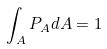Convert formula to latex. <formula><loc_0><loc_0><loc_500><loc_500>\int _ { A } P _ { A } d A = 1</formula> 